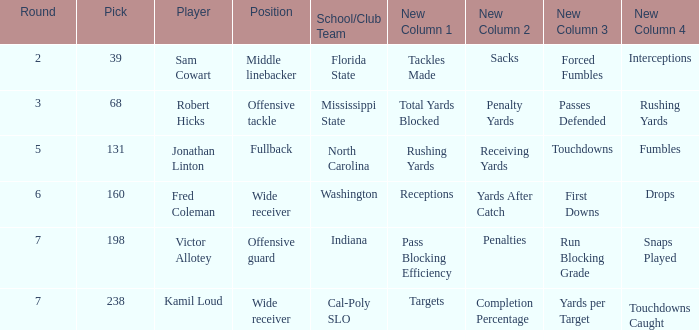Which Round has a School/Club Team of cal-poly slo, and a Pick smaller than 238? None. 